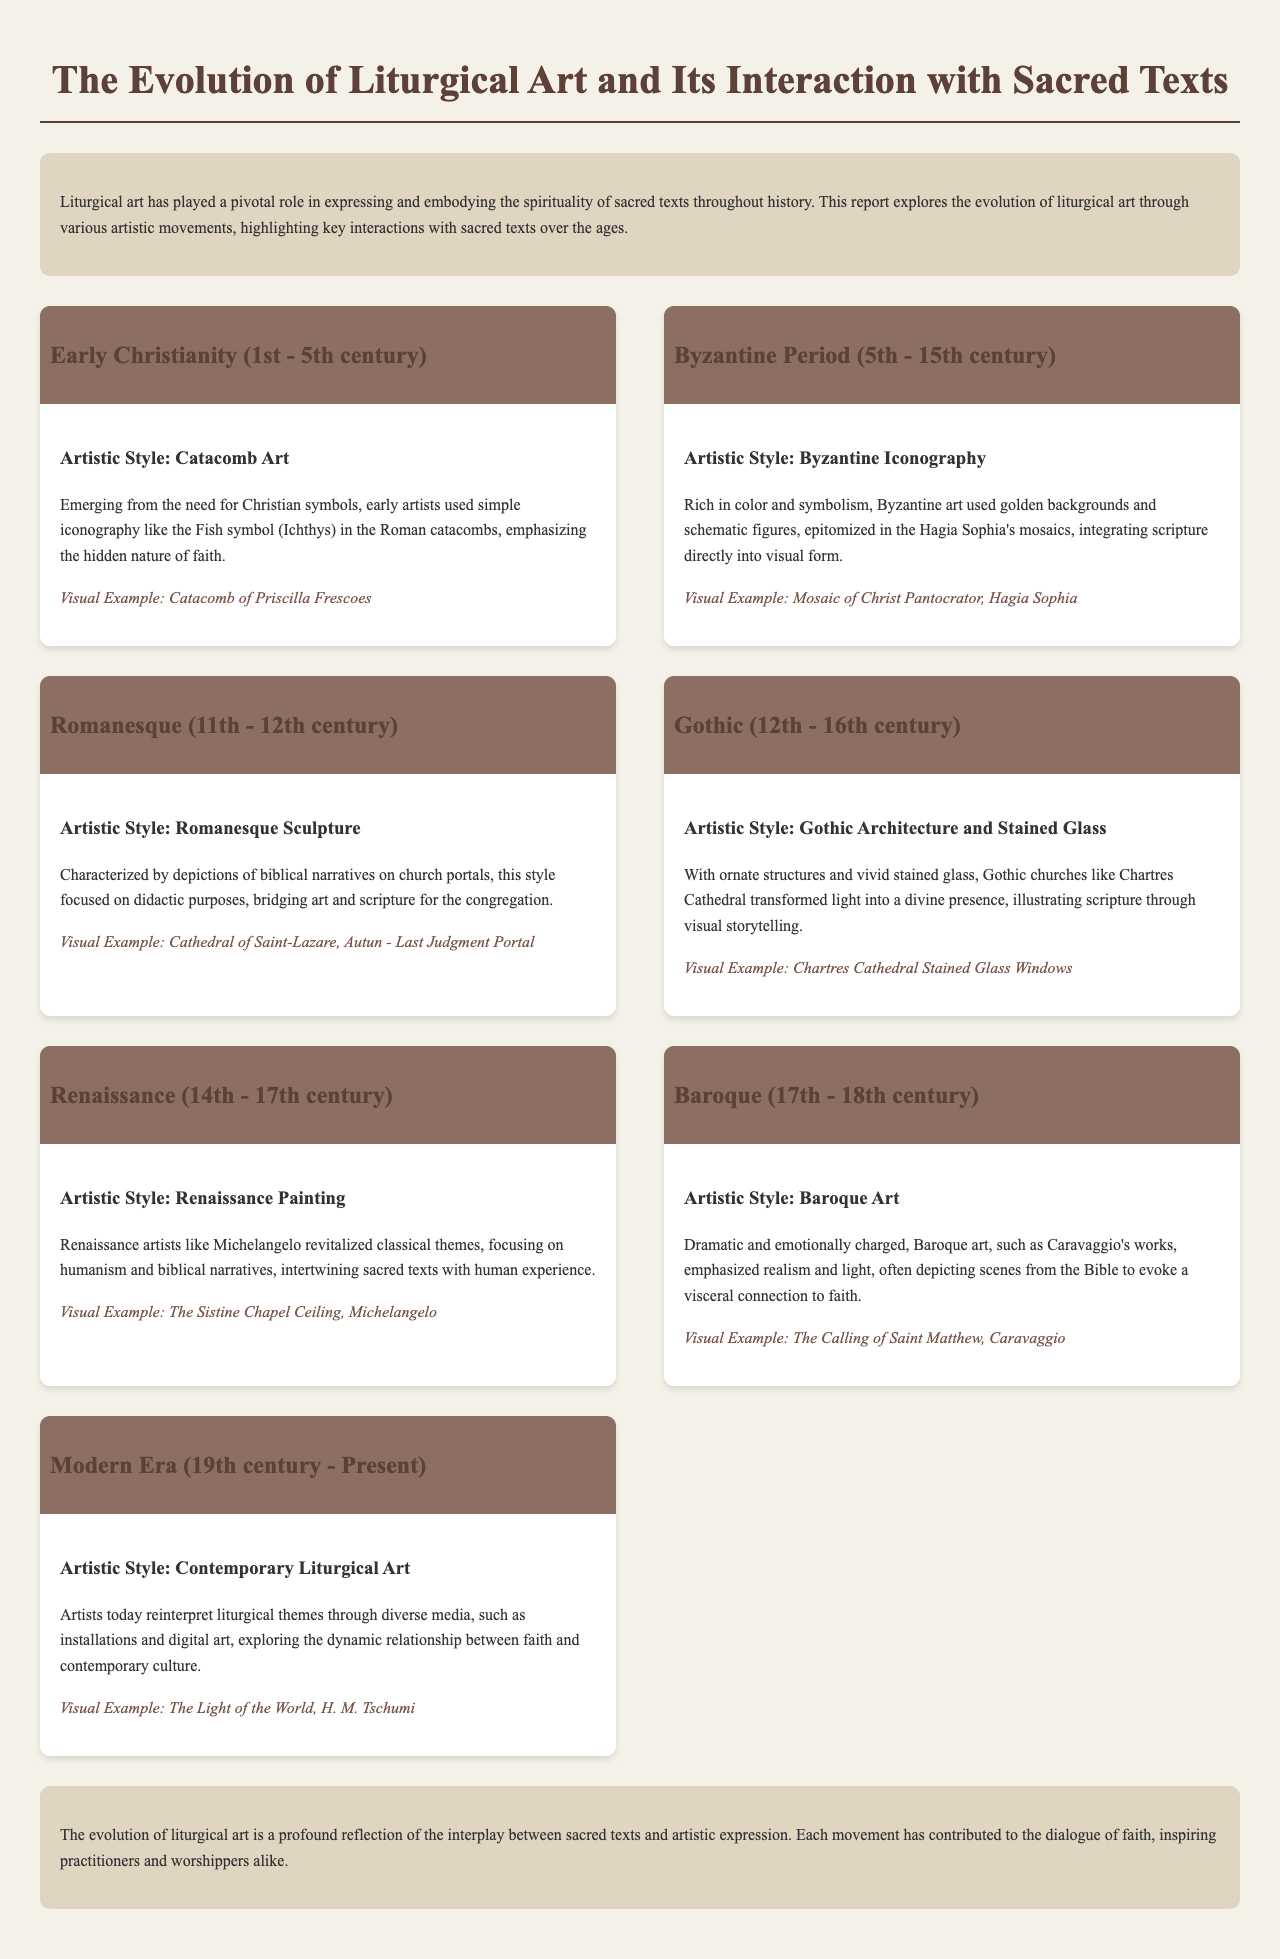what is the time period for Early Christianity? Early Christianity spans from the 1st to the 5th century.
Answer: 1st - 5th century which artistic style is associated with the Byzantine Period? The artistic style for the Byzantine Period is identified as Byzantine Iconography.
Answer: Byzantine Iconography who created the Sistine Chapel Ceiling? The Sistine Chapel Ceiling was created by Michelangelo.
Answer: Michelangelo what is a visual example from the Gothic period? A visual example from the Gothic period is the stained glass windows of Chartres Cathedral.
Answer: Chartres Cathedral Stained Glass Windows how did the Baroque art period depict biblical narratives? Baroque art emphasized realism and light, depicting scenes from the Bible to evoke emotion.
Answer: Realism and light what visual example is cited from the Modern Era? The visual example from the Modern Era is "The Light of the World" by H. M. Tschumi.
Answer: The Light of the World, H. M. Tschumi what is a characteristic feature of Romanesque Sculpture? Romanesque Sculpture is characterized by depictions of biblical narratives on church portals.
Answer: Biblical narratives on church portals during which centuries did the Renaissance take place? The Renaissance took place from the 14th to the 17th century.
Answer: 14th - 17th century what is the primary purpose of art during the Romanesque period? The primary purpose was didactic, bridging art and scripture for the congregation.
Answer: Didactic purposes 